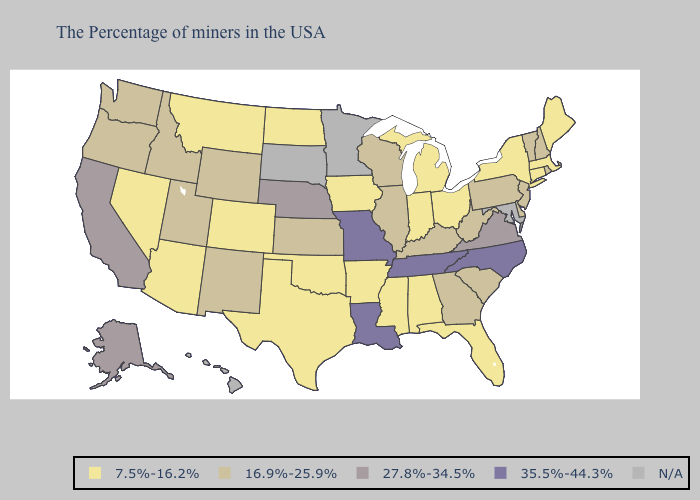Name the states that have a value in the range 27.8%-34.5%?
Short answer required. Virginia, Nebraska, California, Alaska. Which states hav the highest value in the Northeast?
Short answer required. Rhode Island, New Hampshire, Vermont, New Jersey, Pennsylvania. Which states have the highest value in the USA?
Write a very short answer. North Carolina, Tennessee, Louisiana, Missouri. Does Tennessee have the highest value in the USA?
Keep it brief. Yes. Name the states that have a value in the range 7.5%-16.2%?
Quick response, please. Maine, Massachusetts, Connecticut, New York, Ohio, Florida, Michigan, Indiana, Alabama, Mississippi, Arkansas, Iowa, Oklahoma, Texas, North Dakota, Colorado, Montana, Arizona, Nevada. What is the value of Rhode Island?
Write a very short answer. 16.9%-25.9%. Which states have the highest value in the USA?
Answer briefly. North Carolina, Tennessee, Louisiana, Missouri. Which states have the highest value in the USA?
Short answer required. North Carolina, Tennessee, Louisiana, Missouri. What is the lowest value in the USA?
Concise answer only. 7.5%-16.2%. Does the map have missing data?
Answer briefly. Yes. Name the states that have a value in the range 7.5%-16.2%?
Keep it brief. Maine, Massachusetts, Connecticut, New York, Ohio, Florida, Michigan, Indiana, Alabama, Mississippi, Arkansas, Iowa, Oklahoma, Texas, North Dakota, Colorado, Montana, Arizona, Nevada. What is the value of Michigan?
Write a very short answer. 7.5%-16.2%. 